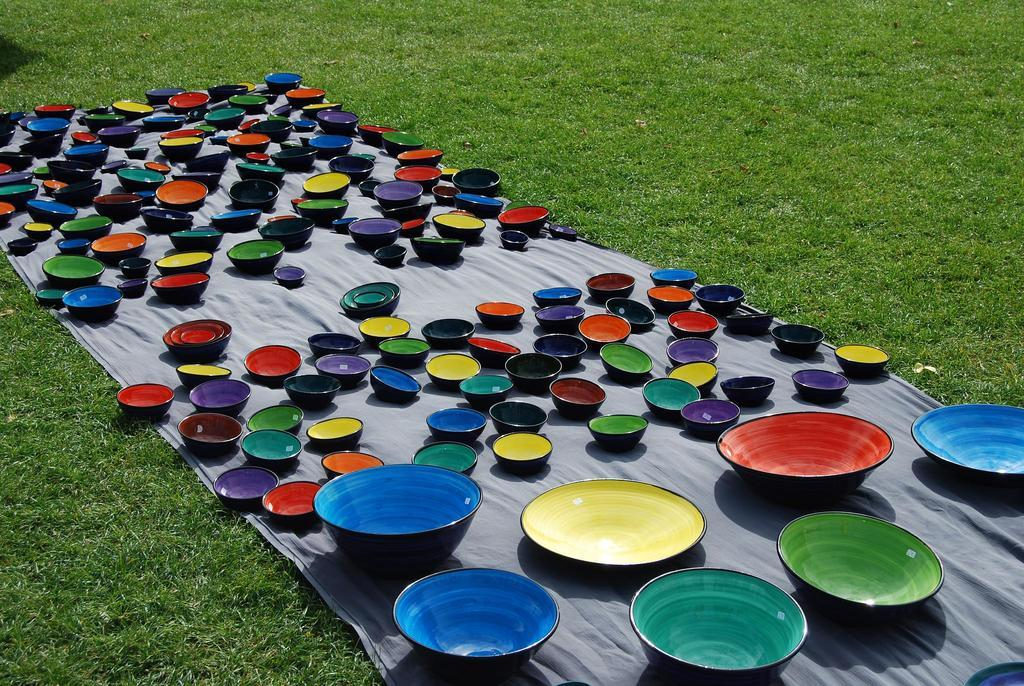Where is the image taken? The image is taken on the grass. What is placed on the grass? There is a cloth on the grass. What can be seen on the cloth? There are bowls with different colors and shapes on the cloth. How many children are combing their hair in the image? There are no children present in the image, and no one is combing their hair. 